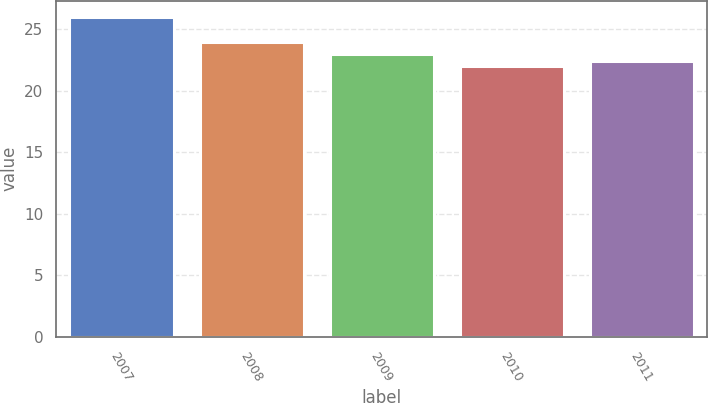Convert chart. <chart><loc_0><loc_0><loc_500><loc_500><bar_chart><fcel>2007<fcel>2008<fcel>2009<fcel>2010<fcel>2011<nl><fcel>26<fcel>24<fcel>23<fcel>22<fcel>22.4<nl></chart> 